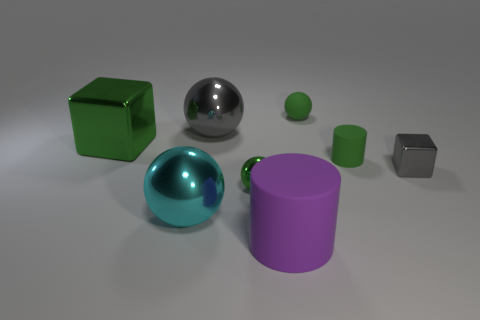Add 1 green rubber cylinders. How many objects exist? 9 Subtract all blocks. How many objects are left? 6 Subtract all big green blocks. Subtract all metallic spheres. How many objects are left? 4 Add 5 green spheres. How many green spheres are left? 7 Add 3 small green things. How many small green things exist? 6 Subtract 0 brown cubes. How many objects are left? 8 